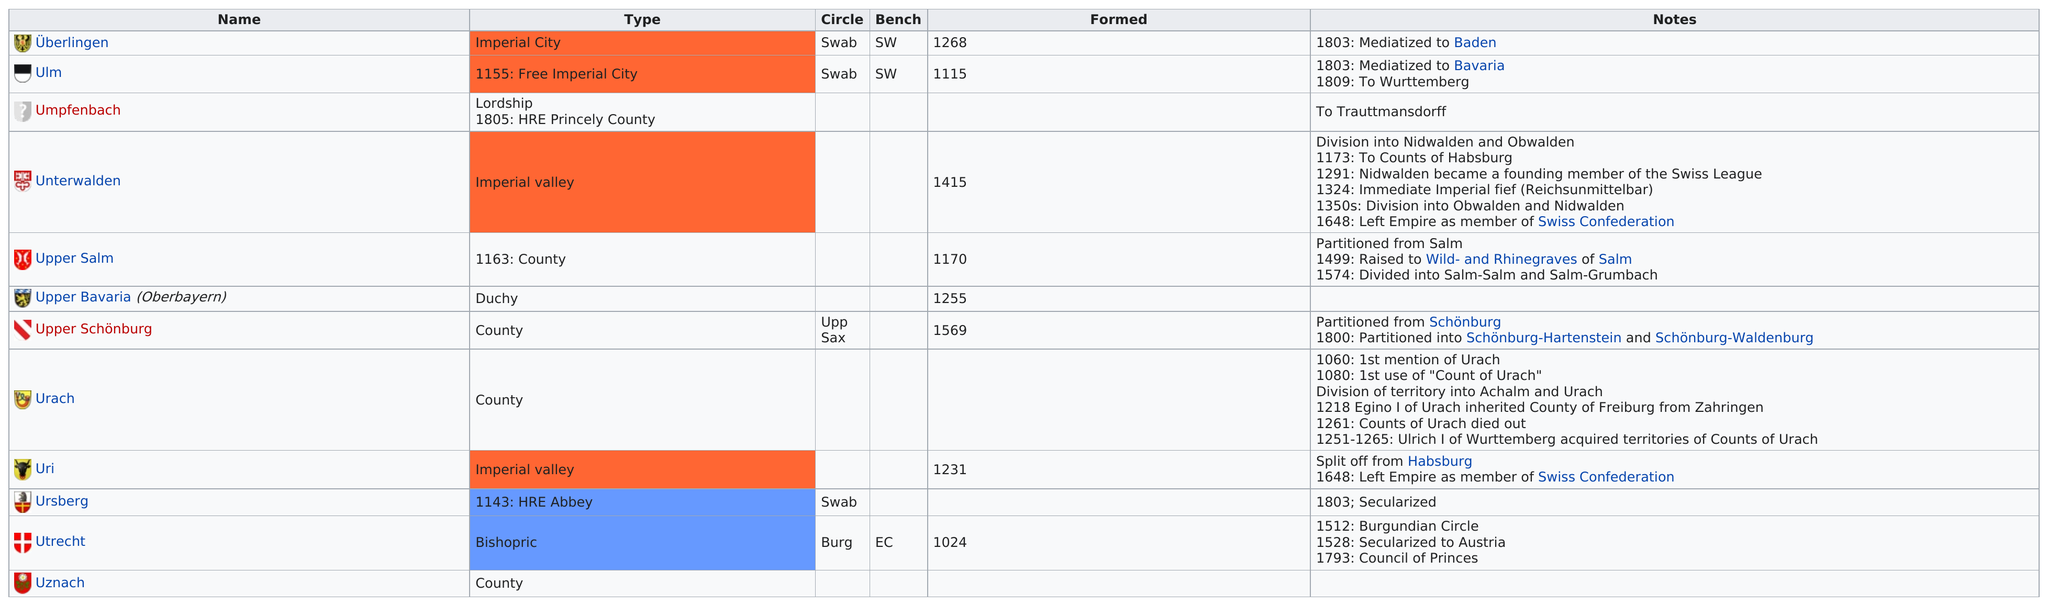Point out several critical features in this image. Other than Ulm, the name of the other imperial city listed is Überlingen. The total number of states formed between 1000 and 1200 is 3. There were 12 states in the Holy Roman Empire that began with the letter 'u.' The state after the urach is the urinary system. Utrecht was the first state to be formed. 